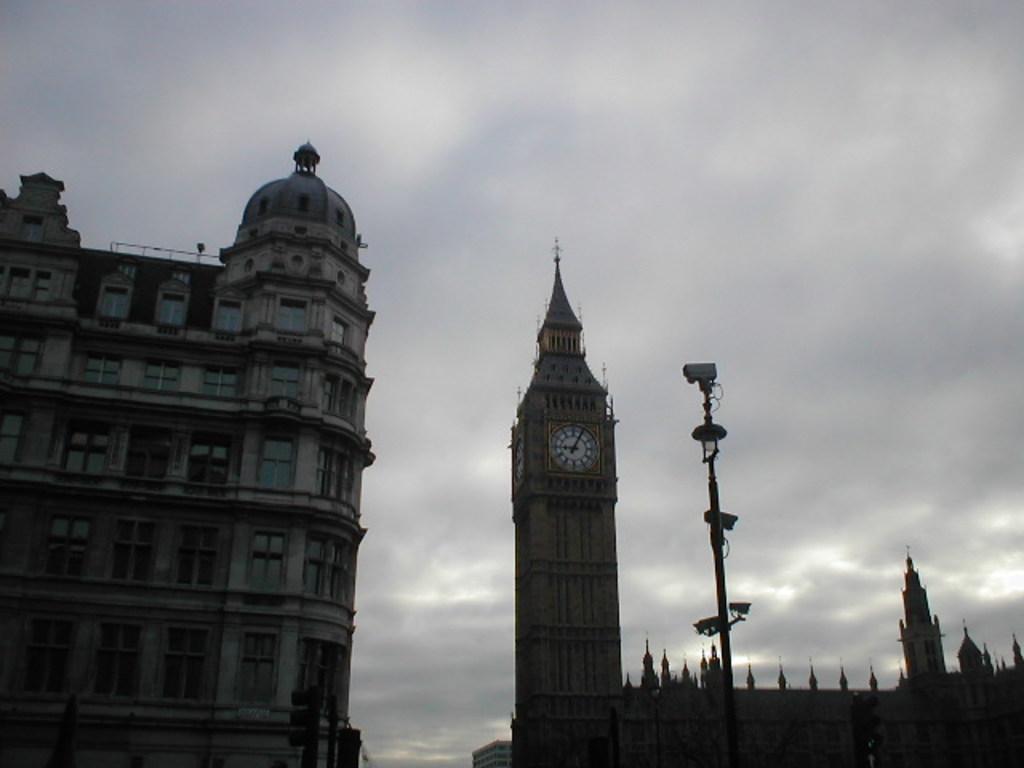Can you describe this image briefly? In this image we can see the buildings with windows and a clock. In front of the building we can see a pole with the cameras. In the background, we can see the sky. 